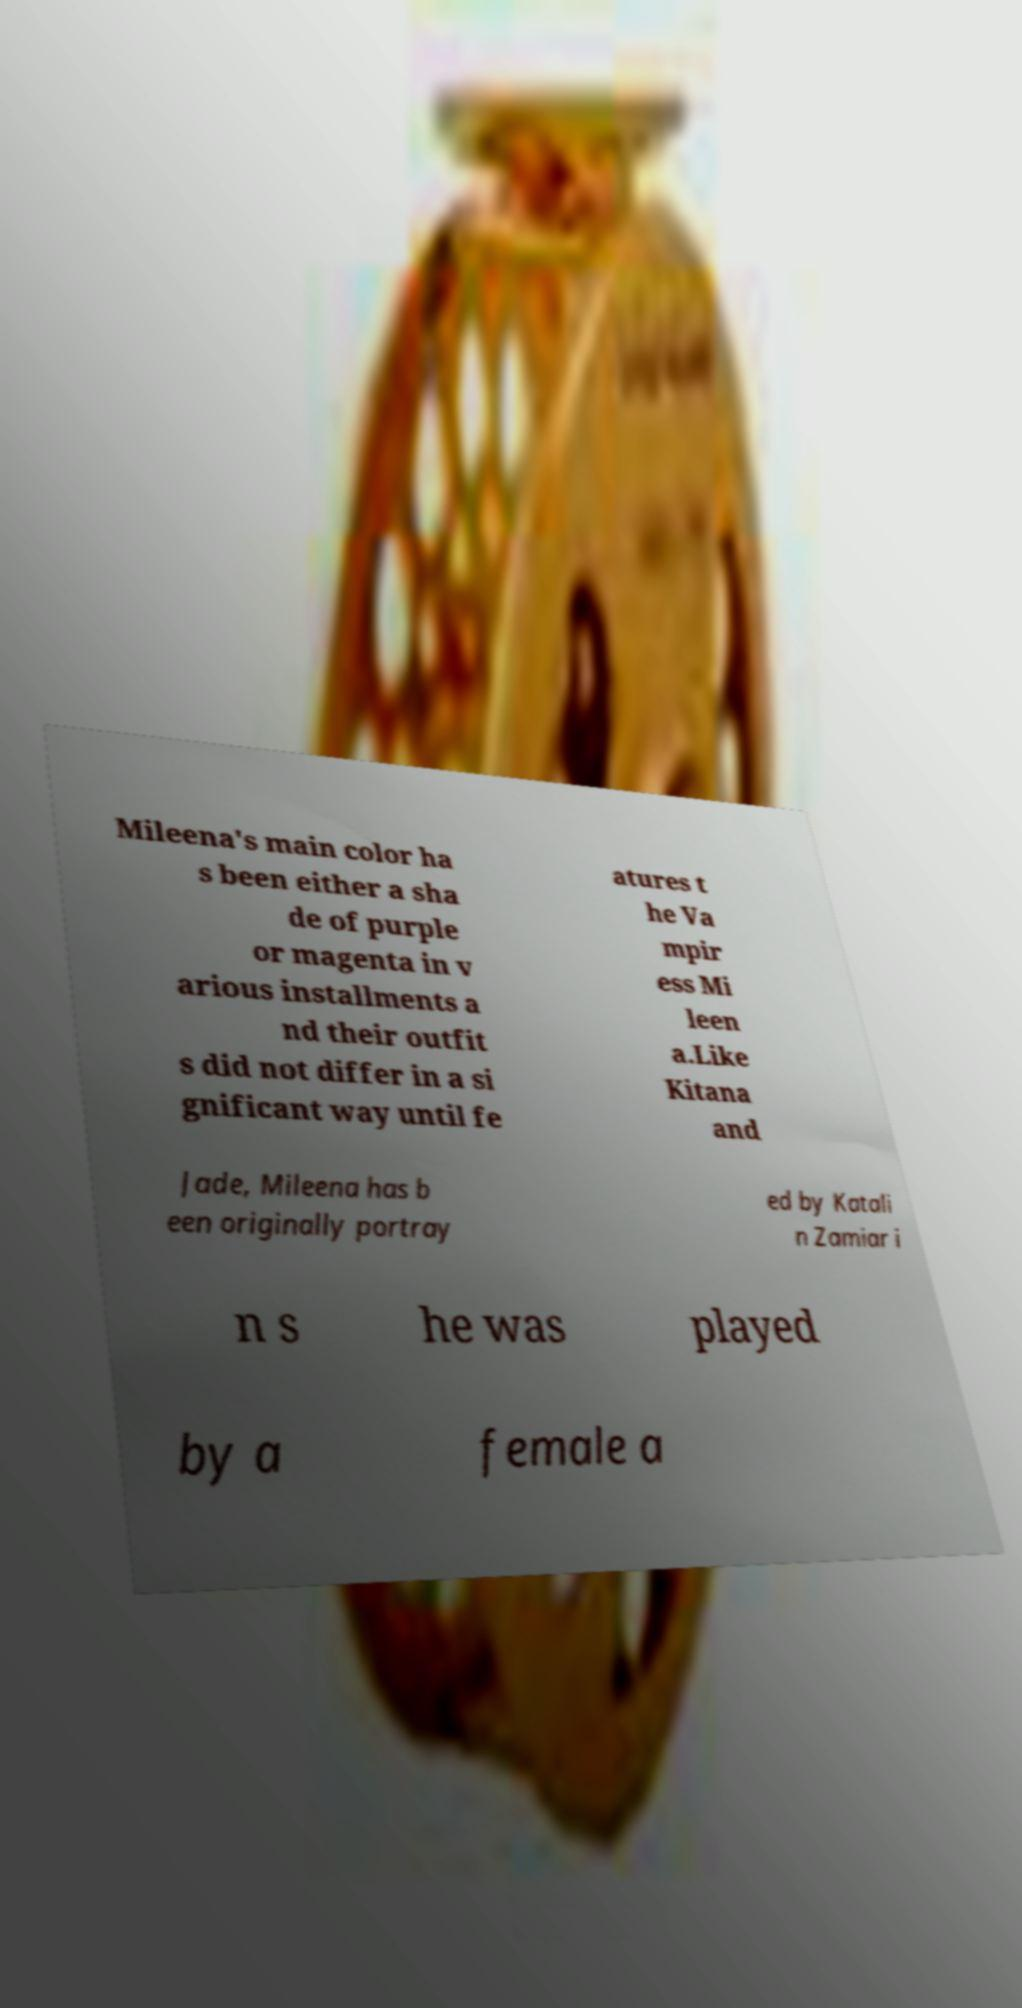What messages or text are displayed in this image? I need them in a readable, typed format. Mileena's main color ha s been either a sha de of purple or magenta in v arious installments a nd their outfit s did not differ in a si gnificant way until fe atures t he Va mpir ess Mi leen a.Like Kitana and Jade, Mileena has b een originally portray ed by Katali n Zamiar i n s he was played by a female a 